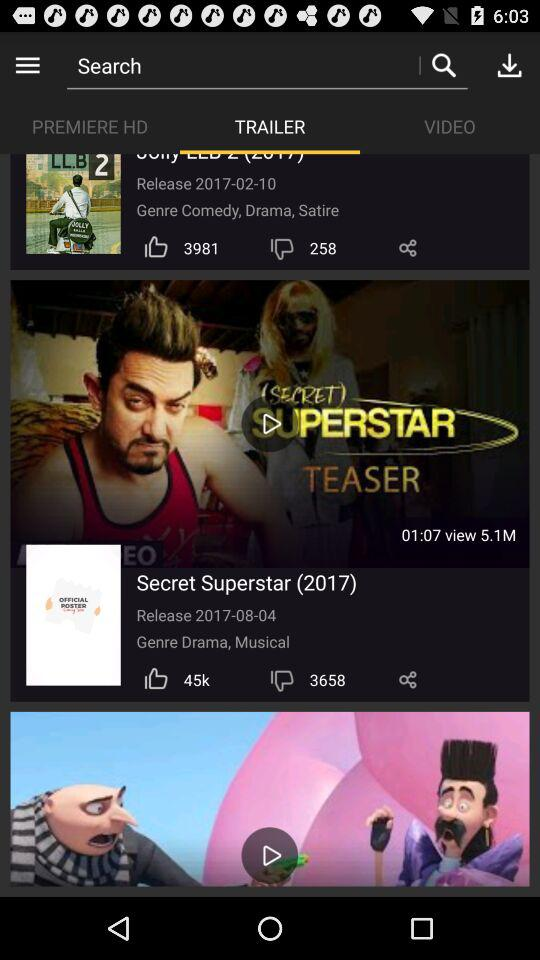How many views are there for the "Secret Superstar"? There are 5.1M views. 